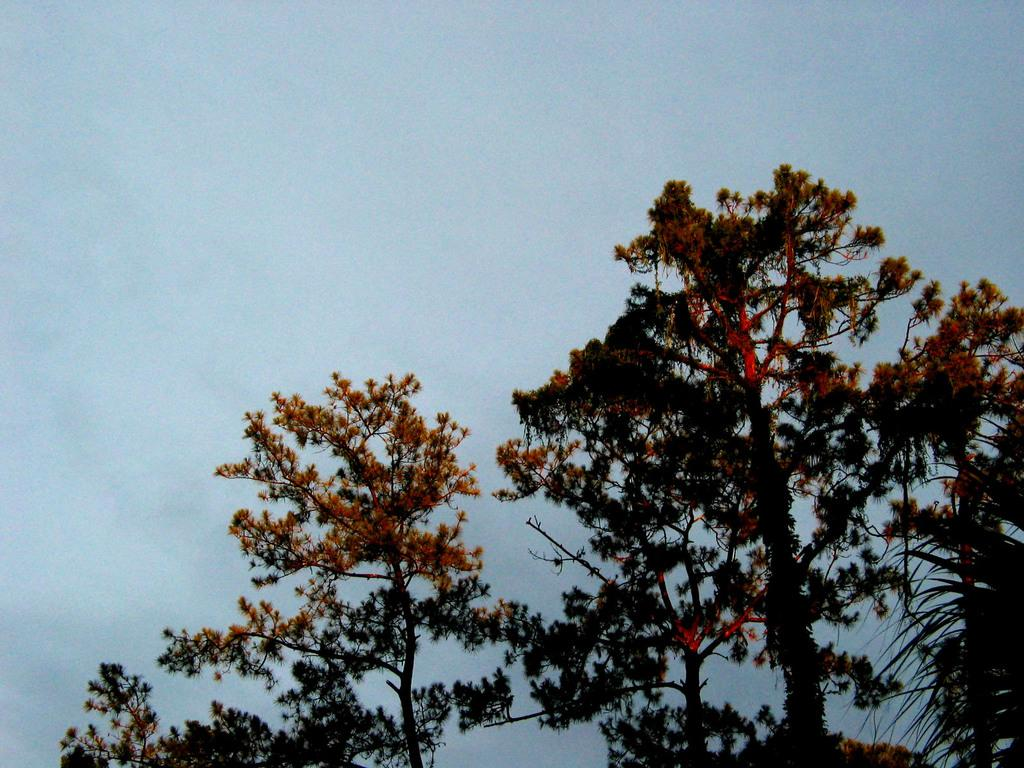What type of vegetation can be seen in the image? There are trees in the image. What part of the natural environment is visible in the image? The sky is visible in the image. What type of bone is being cooked on the stove in the image? There is no stove or bone present in the image; it features trees and the sky. 